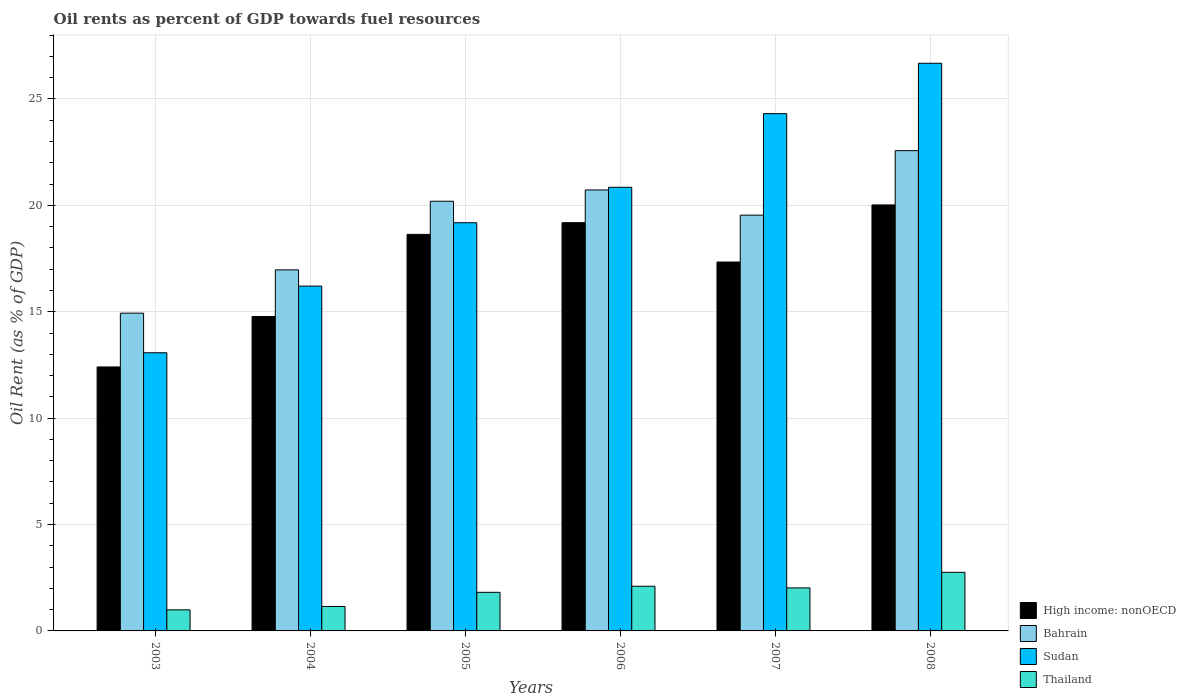Are the number of bars per tick equal to the number of legend labels?
Provide a short and direct response. Yes. How many bars are there on the 3rd tick from the left?
Offer a terse response. 4. How many bars are there on the 5th tick from the right?
Your answer should be very brief. 4. What is the oil rent in Thailand in 2004?
Your answer should be compact. 1.15. Across all years, what is the maximum oil rent in Bahrain?
Make the answer very short. 22.57. Across all years, what is the minimum oil rent in Thailand?
Your answer should be compact. 0.99. In which year was the oil rent in Sudan maximum?
Your answer should be very brief. 2008. In which year was the oil rent in Sudan minimum?
Keep it short and to the point. 2003. What is the total oil rent in Thailand in the graph?
Your answer should be very brief. 10.83. What is the difference between the oil rent in High income: nonOECD in 2005 and that in 2007?
Provide a short and direct response. 1.3. What is the difference between the oil rent in Sudan in 2005 and the oil rent in Thailand in 2004?
Your answer should be compact. 18.03. What is the average oil rent in High income: nonOECD per year?
Your answer should be very brief. 17.06. In the year 2004, what is the difference between the oil rent in Thailand and oil rent in Sudan?
Offer a terse response. -15.06. In how many years, is the oil rent in Thailand greater than 7 %?
Your answer should be compact. 0. What is the ratio of the oil rent in Bahrain in 2005 to that in 2007?
Your response must be concise. 1.03. What is the difference between the highest and the second highest oil rent in High income: nonOECD?
Your response must be concise. 0.83. What is the difference between the highest and the lowest oil rent in High income: nonOECD?
Keep it short and to the point. 7.62. Is the sum of the oil rent in Bahrain in 2007 and 2008 greater than the maximum oil rent in Thailand across all years?
Keep it short and to the point. Yes. Is it the case that in every year, the sum of the oil rent in High income: nonOECD and oil rent in Thailand is greater than the sum of oil rent in Bahrain and oil rent in Sudan?
Ensure brevity in your answer.  No. What does the 2nd bar from the left in 2006 represents?
Make the answer very short. Bahrain. What does the 2nd bar from the right in 2008 represents?
Ensure brevity in your answer.  Sudan. Is it the case that in every year, the sum of the oil rent in Bahrain and oil rent in High income: nonOECD is greater than the oil rent in Thailand?
Make the answer very short. Yes. How many bars are there?
Keep it short and to the point. 24. How many years are there in the graph?
Ensure brevity in your answer.  6. Are the values on the major ticks of Y-axis written in scientific E-notation?
Your answer should be very brief. No. Where does the legend appear in the graph?
Offer a terse response. Bottom right. How are the legend labels stacked?
Give a very brief answer. Vertical. What is the title of the graph?
Keep it short and to the point. Oil rents as percent of GDP towards fuel resources. What is the label or title of the X-axis?
Make the answer very short. Years. What is the label or title of the Y-axis?
Give a very brief answer. Oil Rent (as % of GDP). What is the Oil Rent (as % of GDP) of High income: nonOECD in 2003?
Provide a short and direct response. 12.4. What is the Oil Rent (as % of GDP) of Bahrain in 2003?
Give a very brief answer. 14.93. What is the Oil Rent (as % of GDP) of Sudan in 2003?
Your answer should be very brief. 13.07. What is the Oil Rent (as % of GDP) in Thailand in 2003?
Make the answer very short. 0.99. What is the Oil Rent (as % of GDP) in High income: nonOECD in 2004?
Provide a succinct answer. 14.78. What is the Oil Rent (as % of GDP) in Bahrain in 2004?
Your answer should be compact. 16.97. What is the Oil Rent (as % of GDP) of Sudan in 2004?
Keep it short and to the point. 16.21. What is the Oil Rent (as % of GDP) of Thailand in 2004?
Provide a short and direct response. 1.15. What is the Oil Rent (as % of GDP) of High income: nonOECD in 2005?
Your answer should be compact. 18.64. What is the Oil Rent (as % of GDP) in Bahrain in 2005?
Make the answer very short. 20.19. What is the Oil Rent (as % of GDP) of Sudan in 2005?
Your answer should be very brief. 19.18. What is the Oil Rent (as % of GDP) in Thailand in 2005?
Your answer should be compact. 1.81. What is the Oil Rent (as % of GDP) in High income: nonOECD in 2006?
Your answer should be compact. 19.19. What is the Oil Rent (as % of GDP) in Bahrain in 2006?
Provide a succinct answer. 20.72. What is the Oil Rent (as % of GDP) in Sudan in 2006?
Ensure brevity in your answer.  20.85. What is the Oil Rent (as % of GDP) in Thailand in 2006?
Keep it short and to the point. 2.1. What is the Oil Rent (as % of GDP) in High income: nonOECD in 2007?
Provide a short and direct response. 17.34. What is the Oil Rent (as % of GDP) of Bahrain in 2007?
Your answer should be very brief. 19.54. What is the Oil Rent (as % of GDP) in Sudan in 2007?
Provide a succinct answer. 24.31. What is the Oil Rent (as % of GDP) of Thailand in 2007?
Ensure brevity in your answer.  2.02. What is the Oil Rent (as % of GDP) of High income: nonOECD in 2008?
Keep it short and to the point. 20.02. What is the Oil Rent (as % of GDP) of Bahrain in 2008?
Ensure brevity in your answer.  22.57. What is the Oil Rent (as % of GDP) in Sudan in 2008?
Ensure brevity in your answer.  26.68. What is the Oil Rent (as % of GDP) of Thailand in 2008?
Ensure brevity in your answer.  2.75. Across all years, what is the maximum Oil Rent (as % of GDP) of High income: nonOECD?
Provide a short and direct response. 20.02. Across all years, what is the maximum Oil Rent (as % of GDP) of Bahrain?
Your answer should be compact. 22.57. Across all years, what is the maximum Oil Rent (as % of GDP) in Sudan?
Your response must be concise. 26.68. Across all years, what is the maximum Oil Rent (as % of GDP) of Thailand?
Offer a very short reply. 2.75. Across all years, what is the minimum Oil Rent (as % of GDP) in High income: nonOECD?
Your response must be concise. 12.4. Across all years, what is the minimum Oil Rent (as % of GDP) in Bahrain?
Your response must be concise. 14.93. Across all years, what is the minimum Oil Rent (as % of GDP) in Sudan?
Keep it short and to the point. 13.07. Across all years, what is the minimum Oil Rent (as % of GDP) of Thailand?
Provide a short and direct response. 0.99. What is the total Oil Rent (as % of GDP) in High income: nonOECD in the graph?
Provide a succinct answer. 102.36. What is the total Oil Rent (as % of GDP) in Bahrain in the graph?
Offer a terse response. 114.93. What is the total Oil Rent (as % of GDP) in Sudan in the graph?
Ensure brevity in your answer.  120.3. What is the total Oil Rent (as % of GDP) in Thailand in the graph?
Provide a succinct answer. 10.83. What is the difference between the Oil Rent (as % of GDP) in High income: nonOECD in 2003 and that in 2004?
Give a very brief answer. -2.37. What is the difference between the Oil Rent (as % of GDP) in Bahrain in 2003 and that in 2004?
Your answer should be compact. -2.03. What is the difference between the Oil Rent (as % of GDP) of Sudan in 2003 and that in 2004?
Provide a succinct answer. -3.13. What is the difference between the Oil Rent (as % of GDP) of Thailand in 2003 and that in 2004?
Offer a terse response. -0.16. What is the difference between the Oil Rent (as % of GDP) of High income: nonOECD in 2003 and that in 2005?
Offer a very short reply. -6.23. What is the difference between the Oil Rent (as % of GDP) of Bahrain in 2003 and that in 2005?
Offer a terse response. -5.26. What is the difference between the Oil Rent (as % of GDP) in Sudan in 2003 and that in 2005?
Offer a terse response. -6.11. What is the difference between the Oil Rent (as % of GDP) of Thailand in 2003 and that in 2005?
Make the answer very short. -0.82. What is the difference between the Oil Rent (as % of GDP) in High income: nonOECD in 2003 and that in 2006?
Give a very brief answer. -6.78. What is the difference between the Oil Rent (as % of GDP) of Bahrain in 2003 and that in 2006?
Provide a succinct answer. -5.79. What is the difference between the Oil Rent (as % of GDP) of Sudan in 2003 and that in 2006?
Your answer should be compact. -7.78. What is the difference between the Oil Rent (as % of GDP) of Thailand in 2003 and that in 2006?
Provide a short and direct response. -1.11. What is the difference between the Oil Rent (as % of GDP) in High income: nonOECD in 2003 and that in 2007?
Give a very brief answer. -4.93. What is the difference between the Oil Rent (as % of GDP) in Bahrain in 2003 and that in 2007?
Offer a very short reply. -4.61. What is the difference between the Oil Rent (as % of GDP) in Sudan in 2003 and that in 2007?
Provide a short and direct response. -11.24. What is the difference between the Oil Rent (as % of GDP) in Thailand in 2003 and that in 2007?
Make the answer very short. -1.03. What is the difference between the Oil Rent (as % of GDP) in High income: nonOECD in 2003 and that in 2008?
Keep it short and to the point. -7.62. What is the difference between the Oil Rent (as % of GDP) in Bahrain in 2003 and that in 2008?
Ensure brevity in your answer.  -7.64. What is the difference between the Oil Rent (as % of GDP) in Sudan in 2003 and that in 2008?
Keep it short and to the point. -13.6. What is the difference between the Oil Rent (as % of GDP) in Thailand in 2003 and that in 2008?
Give a very brief answer. -1.76. What is the difference between the Oil Rent (as % of GDP) of High income: nonOECD in 2004 and that in 2005?
Your answer should be very brief. -3.86. What is the difference between the Oil Rent (as % of GDP) in Bahrain in 2004 and that in 2005?
Offer a very short reply. -3.23. What is the difference between the Oil Rent (as % of GDP) of Sudan in 2004 and that in 2005?
Provide a short and direct response. -2.98. What is the difference between the Oil Rent (as % of GDP) of Thailand in 2004 and that in 2005?
Make the answer very short. -0.67. What is the difference between the Oil Rent (as % of GDP) of High income: nonOECD in 2004 and that in 2006?
Your answer should be compact. -4.41. What is the difference between the Oil Rent (as % of GDP) of Bahrain in 2004 and that in 2006?
Offer a very short reply. -3.75. What is the difference between the Oil Rent (as % of GDP) in Sudan in 2004 and that in 2006?
Provide a succinct answer. -4.64. What is the difference between the Oil Rent (as % of GDP) in Thailand in 2004 and that in 2006?
Give a very brief answer. -0.95. What is the difference between the Oil Rent (as % of GDP) of High income: nonOECD in 2004 and that in 2007?
Offer a very short reply. -2.56. What is the difference between the Oil Rent (as % of GDP) in Bahrain in 2004 and that in 2007?
Your answer should be very brief. -2.57. What is the difference between the Oil Rent (as % of GDP) in Sudan in 2004 and that in 2007?
Keep it short and to the point. -8.11. What is the difference between the Oil Rent (as % of GDP) in Thailand in 2004 and that in 2007?
Provide a succinct answer. -0.87. What is the difference between the Oil Rent (as % of GDP) of High income: nonOECD in 2004 and that in 2008?
Provide a short and direct response. -5.24. What is the difference between the Oil Rent (as % of GDP) of Bahrain in 2004 and that in 2008?
Provide a succinct answer. -5.6. What is the difference between the Oil Rent (as % of GDP) of Sudan in 2004 and that in 2008?
Offer a terse response. -10.47. What is the difference between the Oil Rent (as % of GDP) of Thailand in 2004 and that in 2008?
Give a very brief answer. -1.61. What is the difference between the Oil Rent (as % of GDP) in High income: nonOECD in 2005 and that in 2006?
Offer a very short reply. -0.55. What is the difference between the Oil Rent (as % of GDP) in Bahrain in 2005 and that in 2006?
Your answer should be very brief. -0.53. What is the difference between the Oil Rent (as % of GDP) of Sudan in 2005 and that in 2006?
Provide a short and direct response. -1.67. What is the difference between the Oil Rent (as % of GDP) of Thailand in 2005 and that in 2006?
Provide a succinct answer. -0.29. What is the difference between the Oil Rent (as % of GDP) of High income: nonOECD in 2005 and that in 2007?
Offer a terse response. 1.3. What is the difference between the Oil Rent (as % of GDP) in Bahrain in 2005 and that in 2007?
Your response must be concise. 0.65. What is the difference between the Oil Rent (as % of GDP) of Sudan in 2005 and that in 2007?
Ensure brevity in your answer.  -5.13. What is the difference between the Oil Rent (as % of GDP) of Thailand in 2005 and that in 2007?
Keep it short and to the point. -0.21. What is the difference between the Oil Rent (as % of GDP) in High income: nonOECD in 2005 and that in 2008?
Offer a very short reply. -1.38. What is the difference between the Oil Rent (as % of GDP) in Bahrain in 2005 and that in 2008?
Make the answer very short. -2.38. What is the difference between the Oil Rent (as % of GDP) in Sudan in 2005 and that in 2008?
Make the answer very short. -7.49. What is the difference between the Oil Rent (as % of GDP) of Thailand in 2005 and that in 2008?
Your answer should be compact. -0.94. What is the difference between the Oil Rent (as % of GDP) in High income: nonOECD in 2006 and that in 2007?
Give a very brief answer. 1.85. What is the difference between the Oil Rent (as % of GDP) in Bahrain in 2006 and that in 2007?
Ensure brevity in your answer.  1.18. What is the difference between the Oil Rent (as % of GDP) of Sudan in 2006 and that in 2007?
Offer a terse response. -3.46. What is the difference between the Oil Rent (as % of GDP) of Thailand in 2006 and that in 2007?
Your answer should be very brief. 0.08. What is the difference between the Oil Rent (as % of GDP) in High income: nonOECD in 2006 and that in 2008?
Provide a short and direct response. -0.83. What is the difference between the Oil Rent (as % of GDP) of Bahrain in 2006 and that in 2008?
Your answer should be very brief. -1.85. What is the difference between the Oil Rent (as % of GDP) in Sudan in 2006 and that in 2008?
Offer a terse response. -5.83. What is the difference between the Oil Rent (as % of GDP) of Thailand in 2006 and that in 2008?
Give a very brief answer. -0.65. What is the difference between the Oil Rent (as % of GDP) of High income: nonOECD in 2007 and that in 2008?
Provide a succinct answer. -2.68. What is the difference between the Oil Rent (as % of GDP) in Bahrain in 2007 and that in 2008?
Offer a very short reply. -3.03. What is the difference between the Oil Rent (as % of GDP) in Sudan in 2007 and that in 2008?
Your response must be concise. -2.37. What is the difference between the Oil Rent (as % of GDP) of Thailand in 2007 and that in 2008?
Offer a very short reply. -0.73. What is the difference between the Oil Rent (as % of GDP) in High income: nonOECD in 2003 and the Oil Rent (as % of GDP) in Bahrain in 2004?
Make the answer very short. -4.56. What is the difference between the Oil Rent (as % of GDP) in High income: nonOECD in 2003 and the Oil Rent (as % of GDP) in Sudan in 2004?
Your answer should be compact. -3.8. What is the difference between the Oil Rent (as % of GDP) in High income: nonOECD in 2003 and the Oil Rent (as % of GDP) in Thailand in 2004?
Your answer should be very brief. 11.26. What is the difference between the Oil Rent (as % of GDP) in Bahrain in 2003 and the Oil Rent (as % of GDP) in Sudan in 2004?
Keep it short and to the point. -1.27. What is the difference between the Oil Rent (as % of GDP) of Bahrain in 2003 and the Oil Rent (as % of GDP) of Thailand in 2004?
Provide a succinct answer. 13.79. What is the difference between the Oil Rent (as % of GDP) in Sudan in 2003 and the Oil Rent (as % of GDP) in Thailand in 2004?
Make the answer very short. 11.92. What is the difference between the Oil Rent (as % of GDP) in High income: nonOECD in 2003 and the Oil Rent (as % of GDP) in Bahrain in 2005?
Offer a very short reply. -7.79. What is the difference between the Oil Rent (as % of GDP) of High income: nonOECD in 2003 and the Oil Rent (as % of GDP) of Sudan in 2005?
Keep it short and to the point. -6.78. What is the difference between the Oil Rent (as % of GDP) of High income: nonOECD in 2003 and the Oil Rent (as % of GDP) of Thailand in 2005?
Offer a very short reply. 10.59. What is the difference between the Oil Rent (as % of GDP) of Bahrain in 2003 and the Oil Rent (as % of GDP) of Sudan in 2005?
Your answer should be very brief. -4.25. What is the difference between the Oil Rent (as % of GDP) in Bahrain in 2003 and the Oil Rent (as % of GDP) in Thailand in 2005?
Ensure brevity in your answer.  13.12. What is the difference between the Oil Rent (as % of GDP) in Sudan in 2003 and the Oil Rent (as % of GDP) in Thailand in 2005?
Offer a very short reply. 11.26. What is the difference between the Oil Rent (as % of GDP) in High income: nonOECD in 2003 and the Oil Rent (as % of GDP) in Bahrain in 2006?
Your response must be concise. -8.32. What is the difference between the Oil Rent (as % of GDP) of High income: nonOECD in 2003 and the Oil Rent (as % of GDP) of Sudan in 2006?
Ensure brevity in your answer.  -8.44. What is the difference between the Oil Rent (as % of GDP) of High income: nonOECD in 2003 and the Oil Rent (as % of GDP) of Thailand in 2006?
Keep it short and to the point. 10.3. What is the difference between the Oil Rent (as % of GDP) of Bahrain in 2003 and the Oil Rent (as % of GDP) of Sudan in 2006?
Your response must be concise. -5.92. What is the difference between the Oil Rent (as % of GDP) of Bahrain in 2003 and the Oil Rent (as % of GDP) of Thailand in 2006?
Provide a succinct answer. 12.83. What is the difference between the Oil Rent (as % of GDP) of Sudan in 2003 and the Oil Rent (as % of GDP) of Thailand in 2006?
Provide a succinct answer. 10.97. What is the difference between the Oil Rent (as % of GDP) in High income: nonOECD in 2003 and the Oil Rent (as % of GDP) in Bahrain in 2007?
Your answer should be compact. -7.13. What is the difference between the Oil Rent (as % of GDP) of High income: nonOECD in 2003 and the Oil Rent (as % of GDP) of Sudan in 2007?
Your answer should be very brief. -11.91. What is the difference between the Oil Rent (as % of GDP) of High income: nonOECD in 2003 and the Oil Rent (as % of GDP) of Thailand in 2007?
Ensure brevity in your answer.  10.38. What is the difference between the Oil Rent (as % of GDP) in Bahrain in 2003 and the Oil Rent (as % of GDP) in Sudan in 2007?
Your response must be concise. -9.38. What is the difference between the Oil Rent (as % of GDP) of Bahrain in 2003 and the Oil Rent (as % of GDP) of Thailand in 2007?
Your response must be concise. 12.91. What is the difference between the Oil Rent (as % of GDP) of Sudan in 2003 and the Oil Rent (as % of GDP) of Thailand in 2007?
Your response must be concise. 11.05. What is the difference between the Oil Rent (as % of GDP) of High income: nonOECD in 2003 and the Oil Rent (as % of GDP) of Bahrain in 2008?
Give a very brief answer. -10.17. What is the difference between the Oil Rent (as % of GDP) in High income: nonOECD in 2003 and the Oil Rent (as % of GDP) in Sudan in 2008?
Make the answer very short. -14.27. What is the difference between the Oil Rent (as % of GDP) in High income: nonOECD in 2003 and the Oil Rent (as % of GDP) in Thailand in 2008?
Make the answer very short. 9.65. What is the difference between the Oil Rent (as % of GDP) of Bahrain in 2003 and the Oil Rent (as % of GDP) of Sudan in 2008?
Your answer should be very brief. -11.74. What is the difference between the Oil Rent (as % of GDP) of Bahrain in 2003 and the Oil Rent (as % of GDP) of Thailand in 2008?
Offer a terse response. 12.18. What is the difference between the Oil Rent (as % of GDP) of Sudan in 2003 and the Oil Rent (as % of GDP) of Thailand in 2008?
Provide a succinct answer. 10.32. What is the difference between the Oil Rent (as % of GDP) of High income: nonOECD in 2004 and the Oil Rent (as % of GDP) of Bahrain in 2005?
Offer a terse response. -5.42. What is the difference between the Oil Rent (as % of GDP) in High income: nonOECD in 2004 and the Oil Rent (as % of GDP) in Sudan in 2005?
Offer a terse response. -4.41. What is the difference between the Oil Rent (as % of GDP) in High income: nonOECD in 2004 and the Oil Rent (as % of GDP) in Thailand in 2005?
Your response must be concise. 12.96. What is the difference between the Oil Rent (as % of GDP) of Bahrain in 2004 and the Oil Rent (as % of GDP) of Sudan in 2005?
Make the answer very short. -2.21. What is the difference between the Oil Rent (as % of GDP) in Bahrain in 2004 and the Oil Rent (as % of GDP) in Thailand in 2005?
Provide a succinct answer. 15.15. What is the difference between the Oil Rent (as % of GDP) in Sudan in 2004 and the Oil Rent (as % of GDP) in Thailand in 2005?
Make the answer very short. 14.39. What is the difference between the Oil Rent (as % of GDP) of High income: nonOECD in 2004 and the Oil Rent (as % of GDP) of Bahrain in 2006?
Provide a short and direct response. -5.95. What is the difference between the Oil Rent (as % of GDP) of High income: nonOECD in 2004 and the Oil Rent (as % of GDP) of Sudan in 2006?
Offer a very short reply. -6.07. What is the difference between the Oil Rent (as % of GDP) in High income: nonOECD in 2004 and the Oil Rent (as % of GDP) in Thailand in 2006?
Offer a very short reply. 12.68. What is the difference between the Oil Rent (as % of GDP) in Bahrain in 2004 and the Oil Rent (as % of GDP) in Sudan in 2006?
Ensure brevity in your answer.  -3.88. What is the difference between the Oil Rent (as % of GDP) in Bahrain in 2004 and the Oil Rent (as % of GDP) in Thailand in 2006?
Your answer should be compact. 14.87. What is the difference between the Oil Rent (as % of GDP) in Sudan in 2004 and the Oil Rent (as % of GDP) in Thailand in 2006?
Your answer should be compact. 14.11. What is the difference between the Oil Rent (as % of GDP) of High income: nonOECD in 2004 and the Oil Rent (as % of GDP) of Bahrain in 2007?
Provide a short and direct response. -4.76. What is the difference between the Oil Rent (as % of GDP) of High income: nonOECD in 2004 and the Oil Rent (as % of GDP) of Sudan in 2007?
Provide a short and direct response. -9.53. What is the difference between the Oil Rent (as % of GDP) in High income: nonOECD in 2004 and the Oil Rent (as % of GDP) in Thailand in 2007?
Your answer should be very brief. 12.75. What is the difference between the Oil Rent (as % of GDP) in Bahrain in 2004 and the Oil Rent (as % of GDP) in Sudan in 2007?
Make the answer very short. -7.34. What is the difference between the Oil Rent (as % of GDP) in Bahrain in 2004 and the Oil Rent (as % of GDP) in Thailand in 2007?
Make the answer very short. 14.95. What is the difference between the Oil Rent (as % of GDP) of Sudan in 2004 and the Oil Rent (as % of GDP) of Thailand in 2007?
Your response must be concise. 14.18. What is the difference between the Oil Rent (as % of GDP) in High income: nonOECD in 2004 and the Oil Rent (as % of GDP) in Bahrain in 2008?
Offer a very short reply. -7.79. What is the difference between the Oil Rent (as % of GDP) in High income: nonOECD in 2004 and the Oil Rent (as % of GDP) in Sudan in 2008?
Provide a short and direct response. -11.9. What is the difference between the Oil Rent (as % of GDP) in High income: nonOECD in 2004 and the Oil Rent (as % of GDP) in Thailand in 2008?
Make the answer very short. 12.02. What is the difference between the Oil Rent (as % of GDP) of Bahrain in 2004 and the Oil Rent (as % of GDP) of Sudan in 2008?
Give a very brief answer. -9.71. What is the difference between the Oil Rent (as % of GDP) in Bahrain in 2004 and the Oil Rent (as % of GDP) in Thailand in 2008?
Give a very brief answer. 14.21. What is the difference between the Oil Rent (as % of GDP) of Sudan in 2004 and the Oil Rent (as % of GDP) of Thailand in 2008?
Give a very brief answer. 13.45. What is the difference between the Oil Rent (as % of GDP) of High income: nonOECD in 2005 and the Oil Rent (as % of GDP) of Bahrain in 2006?
Keep it short and to the point. -2.09. What is the difference between the Oil Rent (as % of GDP) of High income: nonOECD in 2005 and the Oil Rent (as % of GDP) of Sudan in 2006?
Your answer should be compact. -2.21. What is the difference between the Oil Rent (as % of GDP) of High income: nonOECD in 2005 and the Oil Rent (as % of GDP) of Thailand in 2006?
Keep it short and to the point. 16.54. What is the difference between the Oil Rent (as % of GDP) of Bahrain in 2005 and the Oil Rent (as % of GDP) of Sudan in 2006?
Provide a succinct answer. -0.66. What is the difference between the Oil Rent (as % of GDP) in Bahrain in 2005 and the Oil Rent (as % of GDP) in Thailand in 2006?
Offer a very short reply. 18.09. What is the difference between the Oil Rent (as % of GDP) of Sudan in 2005 and the Oil Rent (as % of GDP) of Thailand in 2006?
Keep it short and to the point. 17.08. What is the difference between the Oil Rent (as % of GDP) of High income: nonOECD in 2005 and the Oil Rent (as % of GDP) of Bahrain in 2007?
Offer a very short reply. -0.9. What is the difference between the Oil Rent (as % of GDP) in High income: nonOECD in 2005 and the Oil Rent (as % of GDP) in Sudan in 2007?
Your response must be concise. -5.67. What is the difference between the Oil Rent (as % of GDP) in High income: nonOECD in 2005 and the Oil Rent (as % of GDP) in Thailand in 2007?
Offer a terse response. 16.61. What is the difference between the Oil Rent (as % of GDP) of Bahrain in 2005 and the Oil Rent (as % of GDP) of Sudan in 2007?
Your response must be concise. -4.12. What is the difference between the Oil Rent (as % of GDP) of Bahrain in 2005 and the Oil Rent (as % of GDP) of Thailand in 2007?
Offer a terse response. 18.17. What is the difference between the Oil Rent (as % of GDP) of Sudan in 2005 and the Oil Rent (as % of GDP) of Thailand in 2007?
Offer a terse response. 17.16. What is the difference between the Oil Rent (as % of GDP) in High income: nonOECD in 2005 and the Oil Rent (as % of GDP) in Bahrain in 2008?
Provide a succinct answer. -3.93. What is the difference between the Oil Rent (as % of GDP) in High income: nonOECD in 2005 and the Oil Rent (as % of GDP) in Sudan in 2008?
Ensure brevity in your answer.  -8.04. What is the difference between the Oil Rent (as % of GDP) of High income: nonOECD in 2005 and the Oil Rent (as % of GDP) of Thailand in 2008?
Make the answer very short. 15.88. What is the difference between the Oil Rent (as % of GDP) of Bahrain in 2005 and the Oil Rent (as % of GDP) of Sudan in 2008?
Your answer should be compact. -6.48. What is the difference between the Oil Rent (as % of GDP) in Bahrain in 2005 and the Oil Rent (as % of GDP) in Thailand in 2008?
Offer a very short reply. 17.44. What is the difference between the Oil Rent (as % of GDP) in Sudan in 2005 and the Oil Rent (as % of GDP) in Thailand in 2008?
Give a very brief answer. 16.43. What is the difference between the Oil Rent (as % of GDP) in High income: nonOECD in 2006 and the Oil Rent (as % of GDP) in Bahrain in 2007?
Make the answer very short. -0.35. What is the difference between the Oil Rent (as % of GDP) of High income: nonOECD in 2006 and the Oil Rent (as % of GDP) of Sudan in 2007?
Provide a short and direct response. -5.12. What is the difference between the Oil Rent (as % of GDP) of High income: nonOECD in 2006 and the Oil Rent (as % of GDP) of Thailand in 2007?
Your answer should be very brief. 17.16. What is the difference between the Oil Rent (as % of GDP) of Bahrain in 2006 and the Oil Rent (as % of GDP) of Sudan in 2007?
Provide a short and direct response. -3.59. What is the difference between the Oil Rent (as % of GDP) of Bahrain in 2006 and the Oil Rent (as % of GDP) of Thailand in 2007?
Offer a very short reply. 18.7. What is the difference between the Oil Rent (as % of GDP) in Sudan in 2006 and the Oil Rent (as % of GDP) in Thailand in 2007?
Provide a short and direct response. 18.83. What is the difference between the Oil Rent (as % of GDP) of High income: nonOECD in 2006 and the Oil Rent (as % of GDP) of Bahrain in 2008?
Offer a terse response. -3.38. What is the difference between the Oil Rent (as % of GDP) of High income: nonOECD in 2006 and the Oil Rent (as % of GDP) of Sudan in 2008?
Your answer should be compact. -7.49. What is the difference between the Oil Rent (as % of GDP) in High income: nonOECD in 2006 and the Oil Rent (as % of GDP) in Thailand in 2008?
Offer a very short reply. 16.43. What is the difference between the Oil Rent (as % of GDP) of Bahrain in 2006 and the Oil Rent (as % of GDP) of Sudan in 2008?
Offer a terse response. -5.95. What is the difference between the Oil Rent (as % of GDP) in Bahrain in 2006 and the Oil Rent (as % of GDP) in Thailand in 2008?
Your answer should be compact. 17.97. What is the difference between the Oil Rent (as % of GDP) of Sudan in 2006 and the Oil Rent (as % of GDP) of Thailand in 2008?
Your answer should be very brief. 18.1. What is the difference between the Oil Rent (as % of GDP) of High income: nonOECD in 2007 and the Oil Rent (as % of GDP) of Bahrain in 2008?
Your answer should be compact. -5.23. What is the difference between the Oil Rent (as % of GDP) of High income: nonOECD in 2007 and the Oil Rent (as % of GDP) of Sudan in 2008?
Your response must be concise. -9.34. What is the difference between the Oil Rent (as % of GDP) of High income: nonOECD in 2007 and the Oil Rent (as % of GDP) of Thailand in 2008?
Provide a succinct answer. 14.58. What is the difference between the Oil Rent (as % of GDP) in Bahrain in 2007 and the Oil Rent (as % of GDP) in Sudan in 2008?
Your answer should be very brief. -7.14. What is the difference between the Oil Rent (as % of GDP) of Bahrain in 2007 and the Oil Rent (as % of GDP) of Thailand in 2008?
Your answer should be compact. 16.79. What is the difference between the Oil Rent (as % of GDP) of Sudan in 2007 and the Oil Rent (as % of GDP) of Thailand in 2008?
Keep it short and to the point. 21.56. What is the average Oil Rent (as % of GDP) of High income: nonOECD per year?
Ensure brevity in your answer.  17.06. What is the average Oil Rent (as % of GDP) in Bahrain per year?
Give a very brief answer. 19.15. What is the average Oil Rent (as % of GDP) of Sudan per year?
Keep it short and to the point. 20.05. What is the average Oil Rent (as % of GDP) of Thailand per year?
Provide a succinct answer. 1.8. In the year 2003, what is the difference between the Oil Rent (as % of GDP) in High income: nonOECD and Oil Rent (as % of GDP) in Bahrain?
Offer a terse response. -2.53. In the year 2003, what is the difference between the Oil Rent (as % of GDP) in High income: nonOECD and Oil Rent (as % of GDP) in Sudan?
Offer a very short reply. -0.67. In the year 2003, what is the difference between the Oil Rent (as % of GDP) of High income: nonOECD and Oil Rent (as % of GDP) of Thailand?
Ensure brevity in your answer.  11.41. In the year 2003, what is the difference between the Oil Rent (as % of GDP) of Bahrain and Oil Rent (as % of GDP) of Sudan?
Provide a succinct answer. 1.86. In the year 2003, what is the difference between the Oil Rent (as % of GDP) in Bahrain and Oil Rent (as % of GDP) in Thailand?
Make the answer very short. 13.94. In the year 2003, what is the difference between the Oil Rent (as % of GDP) of Sudan and Oil Rent (as % of GDP) of Thailand?
Make the answer very short. 12.08. In the year 2004, what is the difference between the Oil Rent (as % of GDP) of High income: nonOECD and Oil Rent (as % of GDP) of Bahrain?
Ensure brevity in your answer.  -2.19. In the year 2004, what is the difference between the Oil Rent (as % of GDP) in High income: nonOECD and Oil Rent (as % of GDP) in Sudan?
Offer a terse response. -1.43. In the year 2004, what is the difference between the Oil Rent (as % of GDP) of High income: nonOECD and Oil Rent (as % of GDP) of Thailand?
Offer a terse response. 13.63. In the year 2004, what is the difference between the Oil Rent (as % of GDP) of Bahrain and Oil Rent (as % of GDP) of Sudan?
Your response must be concise. 0.76. In the year 2004, what is the difference between the Oil Rent (as % of GDP) of Bahrain and Oil Rent (as % of GDP) of Thailand?
Provide a short and direct response. 15.82. In the year 2004, what is the difference between the Oil Rent (as % of GDP) in Sudan and Oil Rent (as % of GDP) in Thailand?
Give a very brief answer. 15.06. In the year 2005, what is the difference between the Oil Rent (as % of GDP) in High income: nonOECD and Oil Rent (as % of GDP) in Bahrain?
Your answer should be compact. -1.56. In the year 2005, what is the difference between the Oil Rent (as % of GDP) in High income: nonOECD and Oil Rent (as % of GDP) in Sudan?
Your answer should be very brief. -0.55. In the year 2005, what is the difference between the Oil Rent (as % of GDP) of High income: nonOECD and Oil Rent (as % of GDP) of Thailand?
Give a very brief answer. 16.82. In the year 2005, what is the difference between the Oil Rent (as % of GDP) in Bahrain and Oil Rent (as % of GDP) in Sudan?
Your response must be concise. 1.01. In the year 2005, what is the difference between the Oil Rent (as % of GDP) of Bahrain and Oil Rent (as % of GDP) of Thailand?
Offer a very short reply. 18.38. In the year 2005, what is the difference between the Oil Rent (as % of GDP) in Sudan and Oil Rent (as % of GDP) in Thailand?
Offer a terse response. 17.37. In the year 2006, what is the difference between the Oil Rent (as % of GDP) in High income: nonOECD and Oil Rent (as % of GDP) in Bahrain?
Your answer should be very brief. -1.54. In the year 2006, what is the difference between the Oil Rent (as % of GDP) in High income: nonOECD and Oil Rent (as % of GDP) in Sudan?
Ensure brevity in your answer.  -1.66. In the year 2006, what is the difference between the Oil Rent (as % of GDP) of High income: nonOECD and Oil Rent (as % of GDP) of Thailand?
Ensure brevity in your answer.  17.09. In the year 2006, what is the difference between the Oil Rent (as % of GDP) of Bahrain and Oil Rent (as % of GDP) of Sudan?
Your answer should be compact. -0.13. In the year 2006, what is the difference between the Oil Rent (as % of GDP) in Bahrain and Oil Rent (as % of GDP) in Thailand?
Keep it short and to the point. 18.62. In the year 2006, what is the difference between the Oil Rent (as % of GDP) of Sudan and Oil Rent (as % of GDP) of Thailand?
Keep it short and to the point. 18.75. In the year 2007, what is the difference between the Oil Rent (as % of GDP) in High income: nonOECD and Oil Rent (as % of GDP) in Bahrain?
Make the answer very short. -2.2. In the year 2007, what is the difference between the Oil Rent (as % of GDP) in High income: nonOECD and Oil Rent (as % of GDP) in Sudan?
Ensure brevity in your answer.  -6.97. In the year 2007, what is the difference between the Oil Rent (as % of GDP) in High income: nonOECD and Oil Rent (as % of GDP) in Thailand?
Your response must be concise. 15.31. In the year 2007, what is the difference between the Oil Rent (as % of GDP) in Bahrain and Oil Rent (as % of GDP) in Sudan?
Your answer should be very brief. -4.77. In the year 2007, what is the difference between the Oil Rent (as % of GDP) of Bahrain and Oil Rent (as % of GDP) of Thailand?
Make the answer very short. 17.52. In the year 2007, what is the difference between the Oil Rent (as % of GDP) in Sudan and Oil Rent (as % of GDP) in Thailand?
Ensure brevity in your answer.  22.29. In the year 2008, what is the difference between the Oil Rent (as % of GDP) of High income: nonOECD and Oil Rent (as % of GDP) of Bahrain?
Offer a very short reply. -2.55. In the year 2008, what is the difference between the Oil Rent (as % of GDP) in High income: nonOECD and Oil Rent (as % of GDP) in Sudan?
Make the answer very short. -6.66. In the year 2008, what is the difference between the Oil Rent (as % of GDP) in High income: nonOECD and Oil Rent (as % of GDP) in Thailand?
Ensure brevity in your answer.  17.27. In the year 2008, what is the difference between the Oil Rent (as % of GDP) of Bahrain and Oil Rent (as % of GDP) of Sudan?
Your answer should be compact. -4.11. In the year 2008, what is the difference between the Oil Rent (as % of GDP) of Bahrain and Oil Rent (as % of GDP) of Thailand?
Ensure brevity in your answer.  19.82. In the year 2008, what is the difference between the Oil Rent (as % of GDP) of Sudan and Oil Rent (as % of GDP) of Thailand?
Make the answer very short. 23.92. What is the ratio of the Oil Rent (as % of GDP) of High income: nonOECD in 2003 to that in 2004?
Your answer should be compact. 0.84. What is the ratio of the Oil Rent (as % of GDP) of Bahrain in 2003 to that in 2004?
Offer a terse response. 0.88. What is the ratio of the Oil Rent (as % of GDP) in Sudan in 2003 to that in 2004?
Make the answer very short. 0.81. What is the ratio of the Oil Rent (as % of GDP) of Thailand in 2003 to that in 2004?
Your response must be concise. 0.86. What is the ratio of the Oil Rent (as % of GDP) in High income: nonOECD in 2003 to that in 2005?
Provide a succinct answer. 0.67. What is the ratio of the Oil Rent (as % of GDP) in Bahrain in 2003 to that in 2005?
Make the answer very short. 0.74. What is the ratio of the Oil Rent (as % of GDP) in Sudan in 2003 to that in 2005?
Offer a very short reply. 0.68. What is the ratio of the Oil Rent (as % of GDP) in Thailand in 2003 to that in 2005?
Make the answer very short. 0.55. What is the ratio of the Oil Rent (as % of GDP) of High income: nonOECD in 2003 to that in 2006?
Your answer should be compact. 0.65. What is the ratio of the Oil Rent (as % of GDP) in Bahrain in 2003 to that in 2006?
Make the answer very short. 0.72. What is the ratio of the Oil Rent (as % of GDP) in Sudan in 2003 to that in 2006?
Make the answer very short. 0.63. What is the ratio of the Oil Rent (as % of GDP) of Thailand in 2003 to that in 2006?
Offer a terse response. 0.47. What is the ratio of the Oil Rent (as % of GDP) in High income: nonOECD in 2003 to that in 2007?
Keep it short and to the point. 0.72. What is the ratio of the Oil Rent (as % of GDP) in Bahrain in 2003 to that in 2007?
Your response must be concise. 0.76. What is the ratio of the Oil Rent (as % of GDP) of Sudan in 2003 to that in 2007?
Give a very brief answer. 0.54. What is the ratio of the Oil Rent (as % of GDP) of Thailand in 2003 to that in 2007?
Give a very brief answer. 0.49. What is the ratio of the Oil Rent (as % of GDP) in High income: nonOECD in 2003 to that in 2008?
Ensure brevity in your answer.  0.62. What is the ratio of the Oil Rent (as % of GDP) of Bahrain in 2003 to that in 2008?
Your response must be concise. 0.66. What is the ratio of the Oil Rent (as % of GDP) in Sudan in 2003 to that in 2008?
Your response must be concise. 0.49. What is the ratio of the Oil Rent (as % of GDP) in Thailand in 2003 to that in 2008?
Provide a succinct answer. 0.36. What is the ratio of the Oil Rent (as % of GDP) in High income: nonOECD in 2004 to that in 2005?
Ensure brevity in your answer.  0.79. What is the ratio of the Oil Rent (as % of GDP) of Bahrain in 2004 to that in 2005?
Provide a short and direct response. 0.84. What is the ratio of the Oil Rent (as % of GDP) in Sudan in 2004 to that in 2005?
Give a very brief answer. 0.84. What is the ratio of the Oil Rent (as % of GDP) of Thailand in 2004 to that in 2005?
Ensure brevity in your answer.  0.63. What is the ratio of the Oil Rent (as % of GDP) in High income: nonOECD in 2004 to that in 2006?
Offer a terse response. 0.77. What is the ratio of the Oil Rent (as % of GDP) of Bahrain in 2004 to that in 2006?
Make the answer very short. 0.82. What is the ratio of the Oil Rent (as % of GDP) of Sudan in 2004 to that in 2006?
Your answer should be very brief. 0.78. What is the ratio of the Oil Rent (as % of GDP) in Thailand in 2004 to that in 2006?
Provide a succinct answer. 0.55. What is the ratio of the Oil Rent (as % of GDP) in High income: nonOECD in 2004 to that in 2007?
Provide a short and direct response. 0.85. What is the ratio of the Oil Rent (as % of GDP) of Bahrain in 2004 to that in 2007?
Give a very brief answer. 0.87. What is the ratio of the Oil Rent (as % of GDP) of Sudan in 2004 to that in 2007?
Your answer should be compact. 0.67. What is the ratio of the Oil Rent (as % of GDP) in Thailand in 2004 to that in 2007?
Your answer should be very brief. 0.57. What is the ratio of the Oil Rent (as % of GDP) in High income: nonOECD in 2004 to that in 2008?
Keep it short and to the point. 0.74. What is the ratio of the Oil Rent (as % of GDP) of Bahrain in 2004 to that in 2008?
Your answer should be compact. 0.75. What is the ratio of the Oil Rent (as % of GDP) of Sudan in 2004 to that in 2008?
Your answer should be very brief. 0.61. What is the ratio of the Oil Rent (as % of GDP) of Thailand in 2004 to that in 2008?
Offer a terse response. 0.42. What is the ratio of the Oil Rent (as % of GDP) of High income: nonOECD in 2005 to that in 2006?
Offer a terse response. 0.97. What is the ratio of the Oil Rent (as % of GDP) in Bahrain in 2005 to that in 2006?
Provide a short and direct response. 0.97. What is the ratio of the Oil Rent (as % of GDP) of Sudan in 2005 to that in 2006?
Make the answer very short. 0.92. What is the ratio of the Oil Rent (as % of GDP) in Thailand in 2005 to that in 2006?
Provide a short and direct response. 0.86. What is the ratio of the Oil Rent (as % of GDP) in High income: nonOECD in 2005 to that in 2007?
Your answer should be very brief. 1.07. What is the ratio of the Oil Rent (as % of GDP) of Bahrain in 2005 to that in 2007?
Keep it short and to the point. 1.03. What is the ratio of the Oil Rent (as % of GDP) of Sudan in 2005 to that in 2007?
Your answer should be very brief. 0.79. What is the ratio of the Oil Rent (as % of GDP) of Thailand in 2005 to that in 2007?
Your answer should be compact. 0.9. What is the ratio of the Oil Rent (as % of GDP) in High income: nonOECD in 2005 to that in 2008?
Give a very brief answer. 0.93. What is the ratio of the Oil Rent (as % of GDP) in Bahrain in 2005 to that in 2008?
Keep it short and to the point. 0.89. What is the ratio of the Oil Rent (as % of GDP) of Sudan in 2005 to that in 2008?
Your response must be concise. 0.72. What is the ratio of the Oil Rent (as % of GDP) of Thailand in 2005 to that in 2008?
Provide a succinct answer. 0.66. What is the ratio of the Oil Rent (as % of GDP) in High income: nonOECD in 2006 to that in 2007?
Provide a succinct answer. 1.11. What is the ratio of the Oil Rent (as % of GDP) of Bahrain in 2006 to that in 2007?
Offer a terse response. 1.06. What is the ratio of the Oil Rent (as % of GDP) of Sudan in 2006 to that in 2007?
Your answer should be compact. 0.86. What is the ratio of the Oil Rent (as % of GDP) of Thailand in 2006 to that in 2007?
Provide a succinct answer. 1.04. What is the ratio of the Oil Rent (as % of GDP) of High income: nonOECD in 2006 to that in 2008?
Give a very brief answer. 0.96. What is the ratio of the Oil Rent (as % of GDP) of Bahrain in 2006 to that in 2008?
Make the answer very short. 0.92. What is the ratio of the Oil Rent (as % of GDP) of Sudan in 2006 to that in 2008?
Provide a short and direct response. 0.78. What is the ratio of the Oil Rent (as % of GDP) of Thailand in 2006 to that in 2008?
Your response must be concise. 0.76. What is the ratio of the Oil Rent (as % of GDP) in High income: nonOECD in 2007 to that in 2008?
Your answer should be compact. 0.87. What is the ratio of the Oil Rent (as % of GDP) in Bahrain in 2007 to that in 2008?
Provide a short and direct response. 0.87. What is the ratio of the Oil Rent (as % of GDP) in Sudan in 2007 to that in 2008?
Keep it short and to the point. 0.91. What is the ratio of the Oil Rent (as % of GDP) of Thailand in 2007 to that in 2008?
Ensure brevity in your answer.  0.73. What is the difference between the highest and the second highest Oil Rent (as % of GDP) of High income: nonOECD?
Offer a terse response. 0.83. What is the difference between the highest and the second highest Oil Rent (as % of GDP) in Bahrain?
Your answer should be compact. 1.85. What is the difference between the highest and the second highest Oil Rent (as % of GDP) of Sudan?
Give a very brief answer. 2.37. What is the difference between the highest and the second highest Oil Rent (as % of GDP) of Thailand?
Keep it short and to the point. 0.65. What is the difference between the highest and the lowest Oil Rent (as % of GDP) of High income: nonOECD?
Your answer should be compact. 7.62. What is the difference between the highest and the lowest Oil Rent (as % of GDP) in Bahrain?
Offer a very short reply. 7.64. What is the difference between the highest and the lowest Oil Rent (as % of GDP) of Sudan?
Provide a short and direct response. 13.6. What is the difference between the highest and the lowest Oil Rent (as % of GDP) in Thailand?
Offer a terse response. 1.76. 